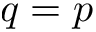<formula> <loc_0><loc_0><loc_500><loc_500>q = p</formula> 